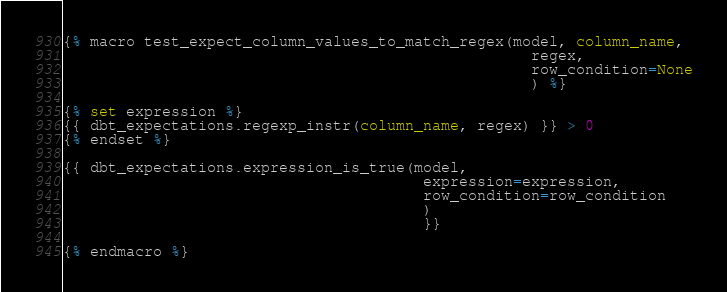<code> <loc_0><loc_0><loc_500><loc_500><_SQL_>{% macro test_expect_column_values_to_match_regex(model, column_name,
                                                    regex,
                                                    row_condition=None
                                                    ) %}

{% set expression %}
{{ dbt_expectations.regexp_instr(column_name, regex) }} > 0
{% endset %}

{{ dbt_expectations.expression_is_true(model,
                                        expression=expression,
                                        row_condition=row_condition
                                        )
                                        }}

{% endmacro %}
</code> 